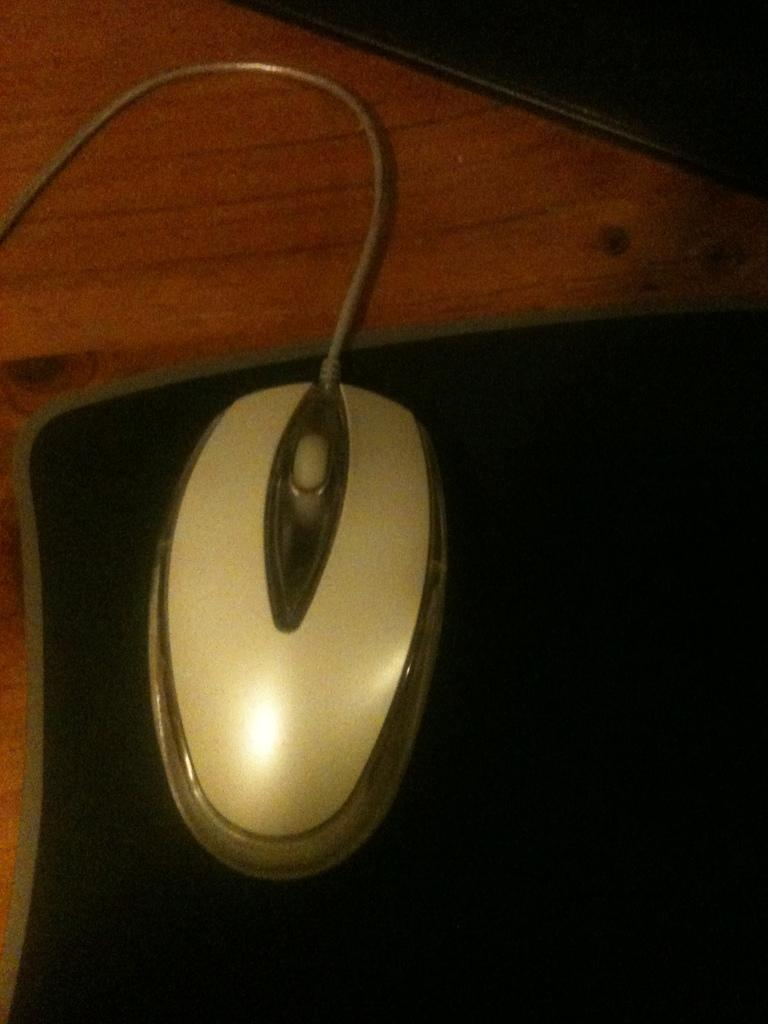What type of animal is in the image? There is a mouse in the image. What is the mouse resting on? The mouse is on a mouse pad. What type of canvas is the mouse teaching on in the image? There is no canvas or teaching activity present in the image; it simply features a mouse on a mouse pad. 